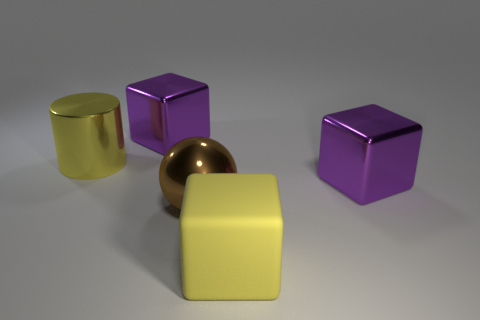What size is the yellow metal cylinder behind the big yellow object in front of the big purple shiny cube that is right of the yellow rubber cube? The yellow metal cylinder appears to be of medium size relative to the objects in the image, positioned behind the large yellow cube and in front of the larger purple cube to the right. 